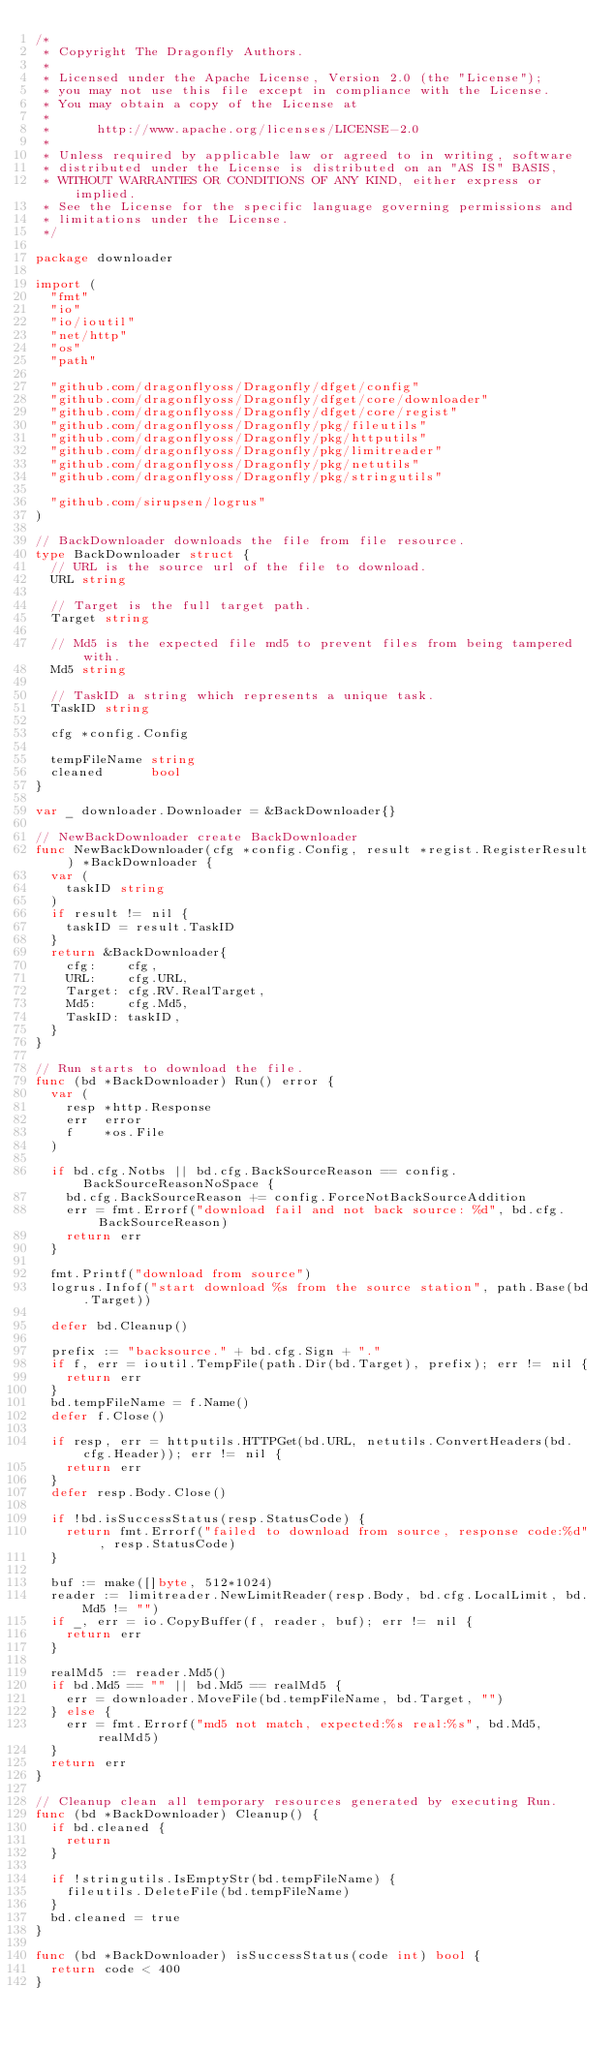<code> <loc_0><loc_0><loc_500><loc_500><_Go_>/*
 * Copyright The Dragonfly Authors.
 *
 * Licensed under the Apache License, Version 2.0 (the "License");
 * you may not use this file except in compliance with the License.
 * You may obtain a copy of the License at
 *
 *      http://www.apache.org/licenses/LICENSE-2.0
 *
 * Unless required by applicable law or agreed to in writing, software
 * distributed under the License is distributed on an "AS IS" BASIS,
 * WITHOUT WARRANTIES OR CONDITIONS OF ANY KIND, either express or implied.
 * See the License for the specific language governing permissions and
 * limitations under the License.
 */

package downloader

import (
	"fmt"
	"io"
	"io/ioutil"
	"net/http"
	"os"
	"path"

	"github.com/dragonflyoss/Dragonfly/dfget/config"
	"github.com/dragonflyoss/Dragonfly/dfget/core/downloader"
	"github.com/dragonflyoss/Dragonfly/dfget/core/regist"
	"github.com/dragonflyoss/Dragonfly/pkg/fileutils"
	"github.com/dragonflyoss/Dragonfly/pkg/httputils"
	"github.com/dragonflyoss/Dragonfly/pkg/limitreader"
	"github.com/dragonflyoss/Dragonfly/pkg/netutils"
	"github.com/dragonflyoss/Dragonfly/pkg/stringutils"

	"github.com/sirupsen/logrus"
)

// BackDownloader downloads the file from file resource.
type BackDownloader struct {
	// URL is the source url of the file to download.
	URL string

	// Target is the full target path.
	Target string

	// Md5 is the expected file md5 to prevent files from being tampered with.
	Md5 string

	// TaskID a string which represents a unique task.
	TaskID string

	cfg *config.Config

	tempFileName string
	cleaned      bool
}

var _ downloader.Downloader = &BackDownloader{}

// NewBackDownloader create BackDownloader
func NewBackDownloader(cfg *config.Config, result *regist.RegisterResult) *BackDownloader {
	var (
		taskID string
	)
	if result != nil {
		taskID = result.TaskID
	}
	return &BackDownloader{
		cfg:    cfg,
		URL:    cfg.URL,
		Target: cfg.RV.RealTarget,
		Md5:    cfg.Md5,
		TaskID: taskID,
	}
}

// Run starts to download the file.
func (bd *BackDownloader) Run() error {
	var (
		resp *http.Response
		err  error
		f    *os.File
	)

	if bd.cfg.Notbs || bd.cfg.BackSourceReason == config.BackSourceReasonNoSpace {
		bd.cfg.BackSourceReason += config.ForceNotBackSourceAddition
		err = fmt.Errorf("download fail and not back source: %d", bd.cfg.BackSourceReason)
		return err
	}

	fmt.Printf("download from source")
	logrus.Infof("start download %s from the source station", path.Base(bd.Target))

	defer bd.Cleanup()

	prefix := "backsource." + bd.cfg.Sign + "."
	if f, err = ioutil.TempFile(path.Dir(bd.Target), prefix); err != nil {
		return err
	}
	bd.tempFileName = f.Name()
	defer f.Close()

	if resp, err = httputils.HTTPGet(bd.URL, netutils.ConvertHeaders(bd.cfg.Header)); err != nil {
		return err
	}
	defer resp.Body.Close()

	if !bd.isSuccessStatus(resp.StatusCode) {
		return fmt.Errorf("failed to download from source, response code:%d", resp.StatusCode)
	}

	buf := make([]byte, 512*1024)
	reader := limitreader.NewLimitReader(resp.Body, bd.cfg.LocalLimit, bd.Md5 != "")
	if _, err = io.CopyBuffer(f, reader, buf); err != nil {
		return err
	}

	realMd5 := reader.Md5()
	if bd.Md5 == "" || bd.Md5 == realMd5 {
		err = downloader.MoveFile(bd.tempFileName, bd.Target, "")
	} else {
		err = fmt.Errorf("md5 not match, expected:%s real:%s", bd.Md5, realMd5)
	}
	return err
}

// Cleanup clean all temporary resources generated by executing Run.
func (bd *BackDownloader) Cleanup() {
	if bd.cleaned {
		return
	}

	if !stringutils.IsEmptyStr(bd.tempFileName) {
		fileutils.DeleteFile(bd.tempFileName)
	}
	bd.cleaned = true
}

func (bd *BackDownloader) isSuccessStatus(code int) bool {
	return code < 400
}
</code> 